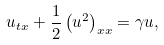<formula> <loc_0><loc_0><loc_500><loc_500>u _ { t x } + \frac { 1 } { 2 } \left ( u ^ { 2 } \right ) _ { x x } = \gamma u ,</formula> 